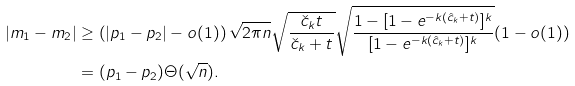Convert formula to latex. <formula><loc_0><loc_0><loc_500><loc_500>| m _ { 1 } - m _ { 2 } | & \geq \left ( | p _ { 1 } - p _ { 2 } | - o ( 1 ) \right ) \sqrt { 2 \pi n } \sqrt { \frac { \check { c } _ { k } t } { \check { c } _ { k } + t } } \sqrt { \frac { 1 - [ 1 - e ^ { - k ( \hat { c } _ { k } + t ) } ] ^ { k } } { [ 1 - e ^ { - k ( \hat { c } _ { k } + t ) } ] ^ { k } } } ( 1 - o ( 1 ) ) \\ & = ( p _ { 1 } - p _ { 2 } ) \Theta ( \sqrt { n } ) .</formula> 